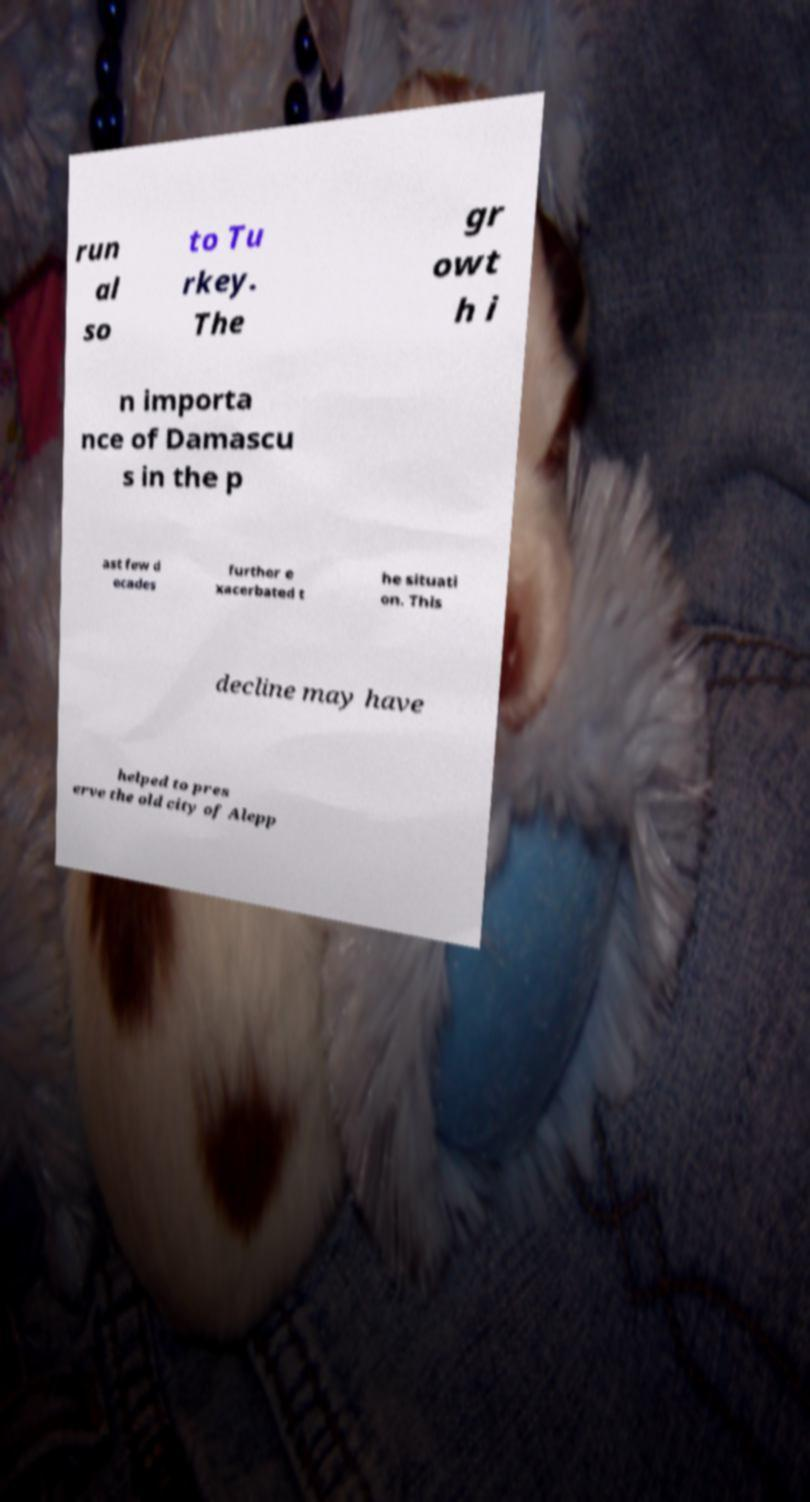There's text embedded in this image that I need extracted. Can you transcribe it verbatim? run al so to Tu rkey. The gr owt h i n importa nce of Damascu s in the p ast few d ecades further e xacerbated t he situati on. This decline may have helped to pres erve the old city of Alepp 